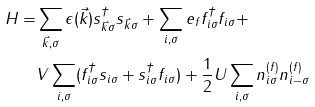Convert formula to latex. <formula><loc_0><loc_0><loc_500><loc_500>H = & \sum _ { \vec { k } , \sigma } \epsilon ( \vec { k } ) s _ { \vec { k } \sigma } ^ { \dagger } s _ { \vec { k } \sigma } + \sum _ { i , \sigma } e _ { f } f _ { i \sigma } ^ { \dagger } f _ { i \sigma } + \\ & V \sum _ { i , \sigma } ( f _ { i \sigma } ^ { \dagger } s _ { i \sigma } + s _ { i \sigma } ^ { \dagger } f _ { i \sigma } ) + \frac { 1 } { 2 } U \sum _ { i , \sigma } n _ { i \sigma } ^ { ( f ) } n _ { i - \sigma } ^ { ( f ) }</formula> 